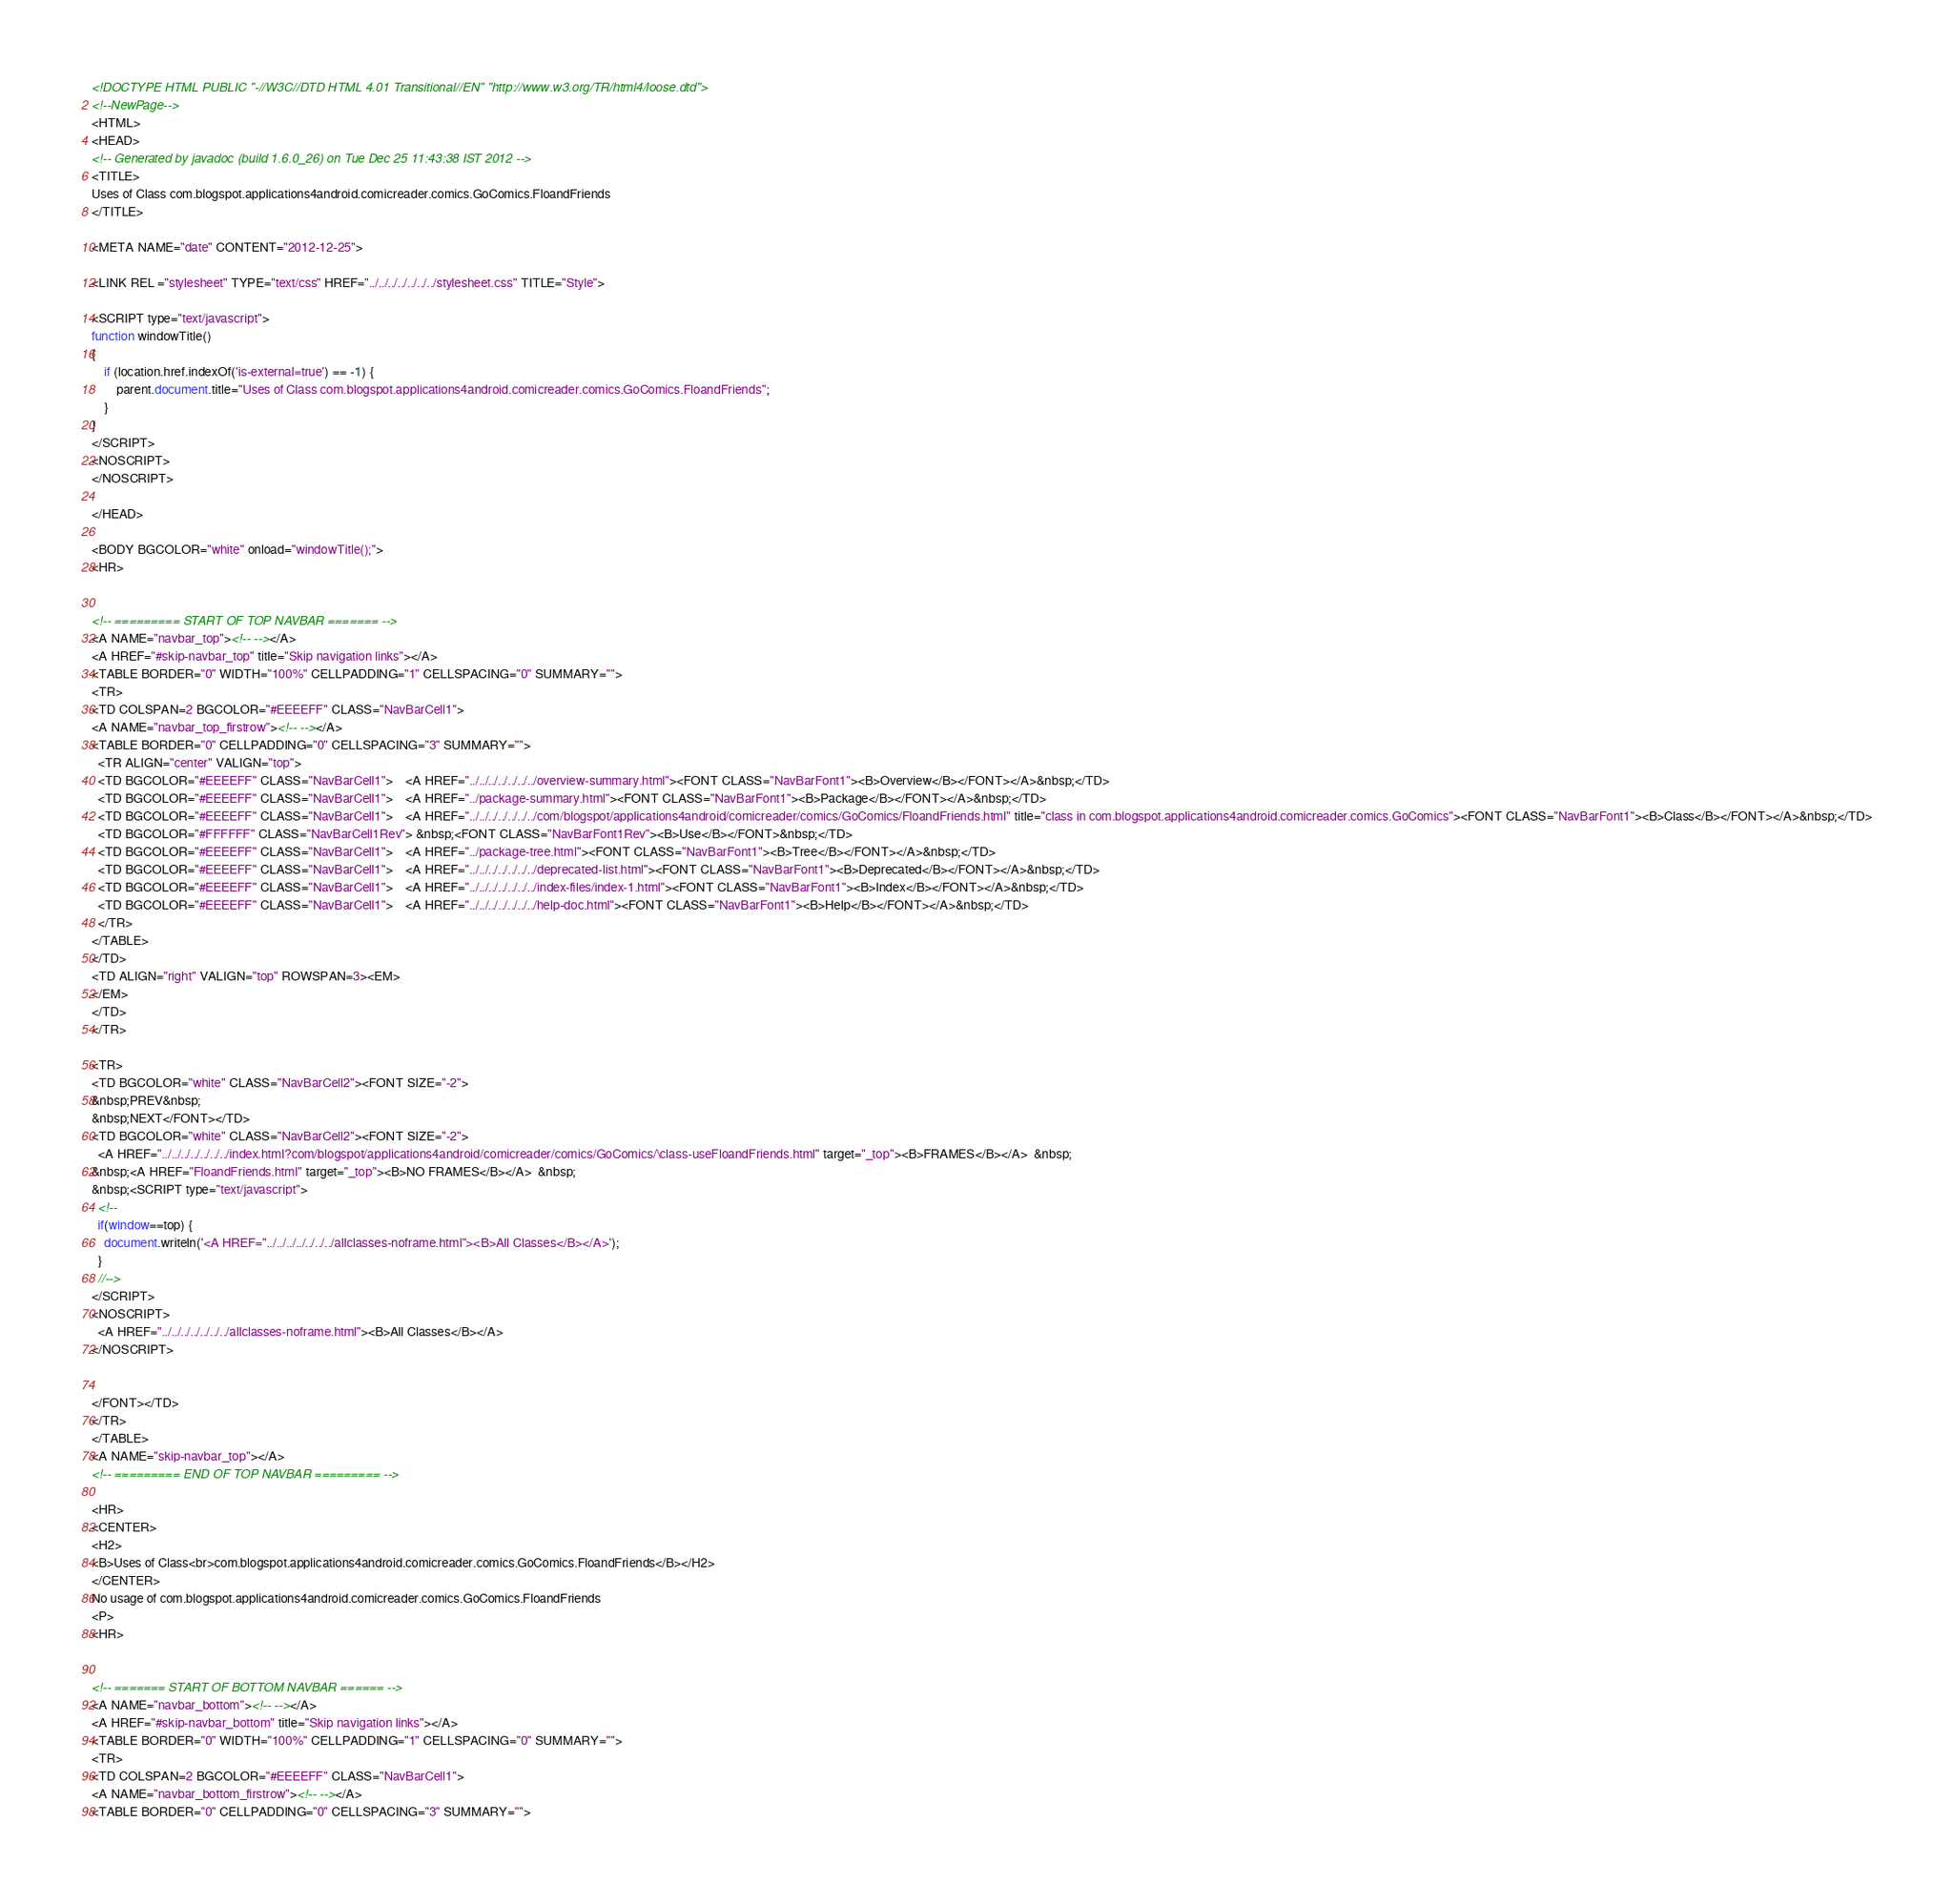<code> <loc_0><loc_0><loc_500><loc_500><_HTML_><!DOCTYPE HTML PUBLIC "-//W3C//DTD HTML 4.01 Transitional//EN" "http://www.w3.org/TR/html4/loose.dtd">
<!--NewPage-->
<HTML>
<HEAD>
<!-- Generated by javadoc (build 1.6.0_26) on Tue Dec 25 11:43:38 IST 2012 -->
<TITLE>
Uses of Class com.blogspot.applications4android.comicreader.comics.GoComics.FloandFriends
</TITLE>

<META NAME="date" CONTENT="2012-12-25">

<LINK REL ="stylesheet" TYPE="text/css" HREF="../../../../../../../stylesheet.css" TITLE="Style">

<SCRIPT type="text/javascript">
function windowTitle()
{
    if (location.href.indexOf('is-external=true') == -1) {
        parent.document.title="Uses of Class com.blogspot.applications4android.comicreader.comics.GoComics.FloandFriends";
    }
}
</SCRIPT>
<NOSCRIPT>
</NOSCRIPT>

</HEAD>

<BODY BGCOLOR="white" onload="windowTitle();">
<HR>


<!-- ========= START OF TOP NAVBAR ======= -->
<A NAME="navbar_top"><!-- --></A>
<A HREF="#skip-navbar_top" title="Skip navigation links"></A>
<TABLE BORDER="0" WIDTH="100%" CELLPADDING="1" CELLSPACING="0" SUMMARY="">
<TR>
<TD COLSPAN=2 BGCOLOR="#EEEEFF" CLASS="NavBarCell1">
<A NAME="navbar_top_firstrow"><!-- --></A>
<TABLE BORDER="0" CELLPADDING="0" CELLSPACING="3" SUMMARY="">
  <TR ALIGN="center" VALIGN="top">
  <TD BGCOLOR="#EEEEFF" CLASS="NavBarCell1">    <A HREF="../../../../../../../overview-summary.html"><FONT CLASS="NavBarFont1"><B>Overview</B></FONT></A>&nbsp;</TD>
  <TD BGCOLOR="#EEEEFF" CLASS="NavBarCell1">    <A HREF="../package-summary.html"><FONT CLASS="NavBarFont1"><B>Package</B></FONT></A>&nbsp;</TD>
  <TD BGCOLOR="#EEEEFF" CLASS="NavBarCell1">    <A HREF="../../../../../../../com/blogspot/applications4android/comicreader/comics/GoComics/FloandFriends.html" title="class in com.blogspot.applications4android.comicreader.comics.GoComics"><FONT CLASS="NavBarFont1"><B>Class</B></FONT></A>&nbsp;</TD>
  <TD BGCOLOR="#FFFFFF" CLASS="NavBarCell1Rev"> &nbsp;<FONT CLASS="NavBarFont1Rev"><B>Use</B></FONT>&nbsp;</TD>
  <TD BGCOLOR="#EEEEFF" CLASS="NavBarCell1">    <A HREF="../package-tree.html"><FONT CLASS="NavBarFont1"><B>Tree</B></FONT></A>&nbsp;</TD>
  <TD BGCOLOR="#EEEEFF" CLASS="NavBarCell1">    <A HREF="../../../../../../../deprecated-list.html"><FONT CLASS="NavBarFont1"><B>Deprecated</B></FONT></A>&nbsp;</TD>
  <TD BGCOLOR="#EEEEFF" CLASS="NavBarCell1">    <A HREF="../../../../../../../index-files/index-1.html"><FONT CLASS="NavBarFont1"><B>Index</B></FONT></A>&nbsp;</TD>
  <TD BGCOLOR="#EEEEFF" CLASS="NavBarCell1">    <A HREF="../../../../../../../help-doc.html"><FONT CLASS="NavBarFont1"><B>Help</B></FONT></A>&nbsp;</TD>
  </TR>
</TABLE>
</TD>
<TD ALIGN="right" VALIGN="top" ROWSPAN=3><EM>
</EM>
</TD>
</TR>

<TR>
<TD BGCOLOR="white" CLASS="NavBarCell2"><FONT SIZE="-2">
&nbsp;PREV&nbsp;
&nbsp;NEXT</FONT></TD>
<TD BGCOLOR="white" CLASS="NavBarCell2"><FONT SIZE="-2">
  <A HREF="../../../../../../../index.html?com/blogspot/applications4android/comicreader/comics/GoComics/\class-useFloandFriends.html" target="_top"><B>FRAMES</B></A>  &nbsp;
&nbsp;<A HREF="FloandFriends.html" target="_top"><B>NO FRAMES</B></A>  &nbsp;
&nbsp;<SCRIPT type="text/javascript">
  <!--
  if(window==top) {
    document.writeln('<A HREF="../../../../../../../allclasses-noframe.html"><B>All Classes</B></A>');
  }
  //-->
</SCRIPT>
<NOSCRIPT>
  <A HREF="../../../../../../../allclasses-noframe.html"><B>All Classes</B></A>
</NOSCRIPT>


</FONT></TD>
</TR>
</TABLE>
<A NAME="skip-navbar_top"></A>
<!-- ========= END OF TOP NAVBAR ========= -->

<HR>
<CENTER>
<H2>
<B>Uses of Class<br>com.blogspot.applications4android.comicreader.comics.GoComics.FloandFriends</B></H2>
</CENTER>
No usage of com.blogspot.applications4android.comicreader.comics.GoComics.FloandFriends
<P>
<HR>


<!-- ======= START OF BOTTOM NAVBAR ====== -->
<A NAME="navbar_bottom"><!-- --></A>
<A HREF="#skip-navbar_bottom" title="Skip navigation links"></A>
<TABLE BORDER="0" WIDTH="100%" CELLPADDING="1" CELLSPACING="0" SUMMARY="">
<TR>
<TD COLSPAN=2 BGCOLOR="#EEEEFF" CLASS="NavBarCell1">
<A NAME="navbar_bottom_firstrow"><!-- --></A>
<TABLE BORDER="0" CELLPADDING="0" CELLSPACING="3" SUMMARY=""></code> 